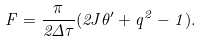<formula> <loc_0><loc_0><loc_500><loc_500>F = \frac { \pi } { 2 \Delta \tau } ( 2 J \theta ^ { \prime } + q ^ { 2 } - 1 ) .</formula> 